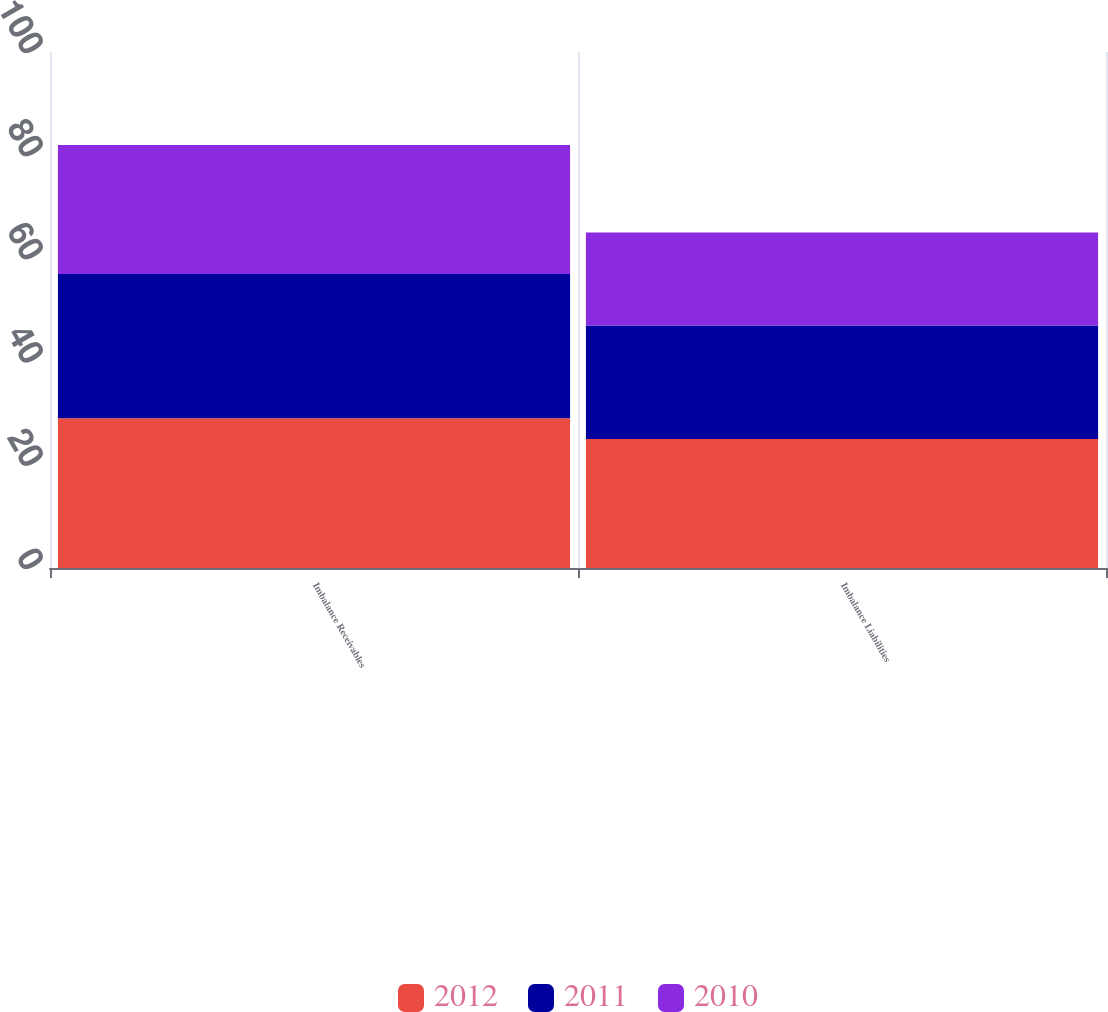<chart> <loc_0><loc_0><loc_500><loc_500><stacked_bar_chart><ecel><fcel>Imbalance Receivables<fcel>Imbalance Liabilities<nl><fcel>2012<fcel>29<fcel>25<nl><fcel>2011<fcel>28<fcel>22<nl><fcel>2010<fcel>25<fcel>18<nl></chart> 